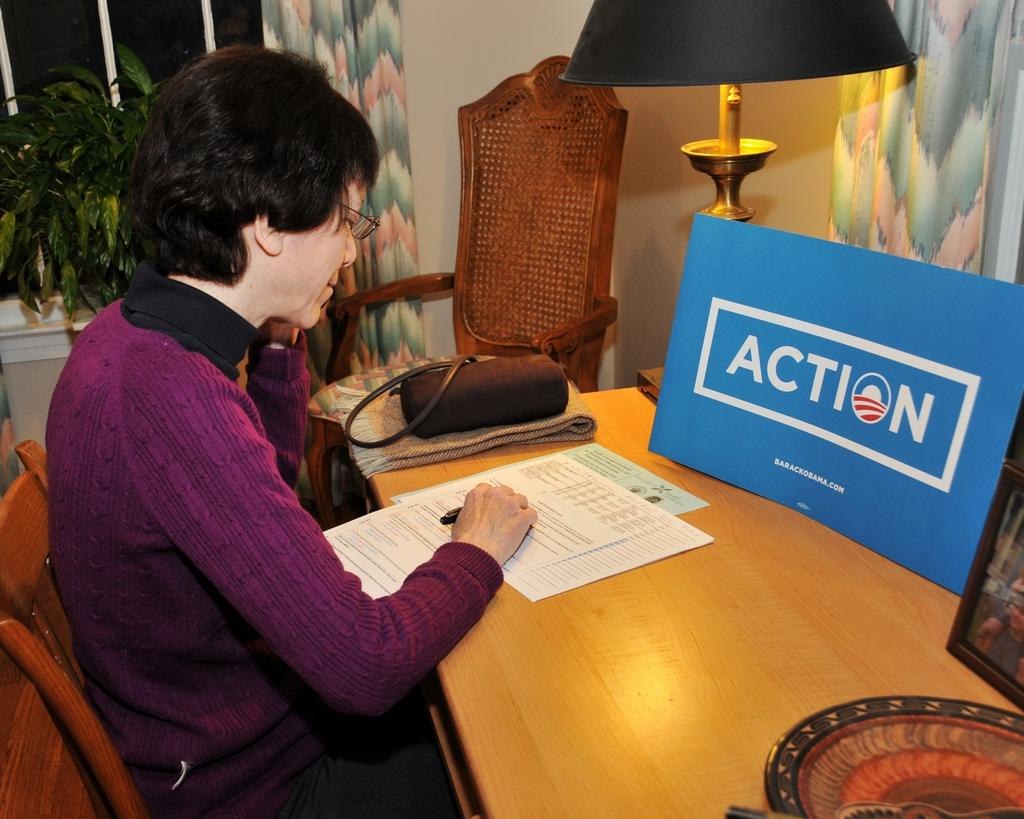<image>
Write a terse but informative summary of the picture. Older lady sitting at a desk with a lamp in front of a Action sign from Obama's campaign. 